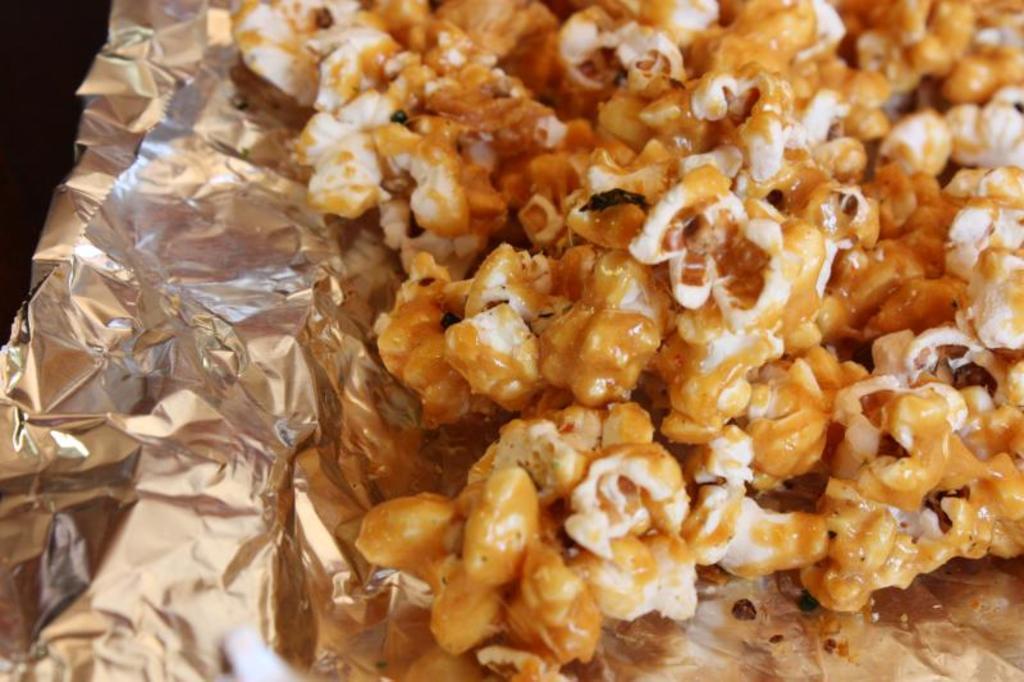Describe this image in one or two sentences. In this picture we can see pop corns on the foil paper. 